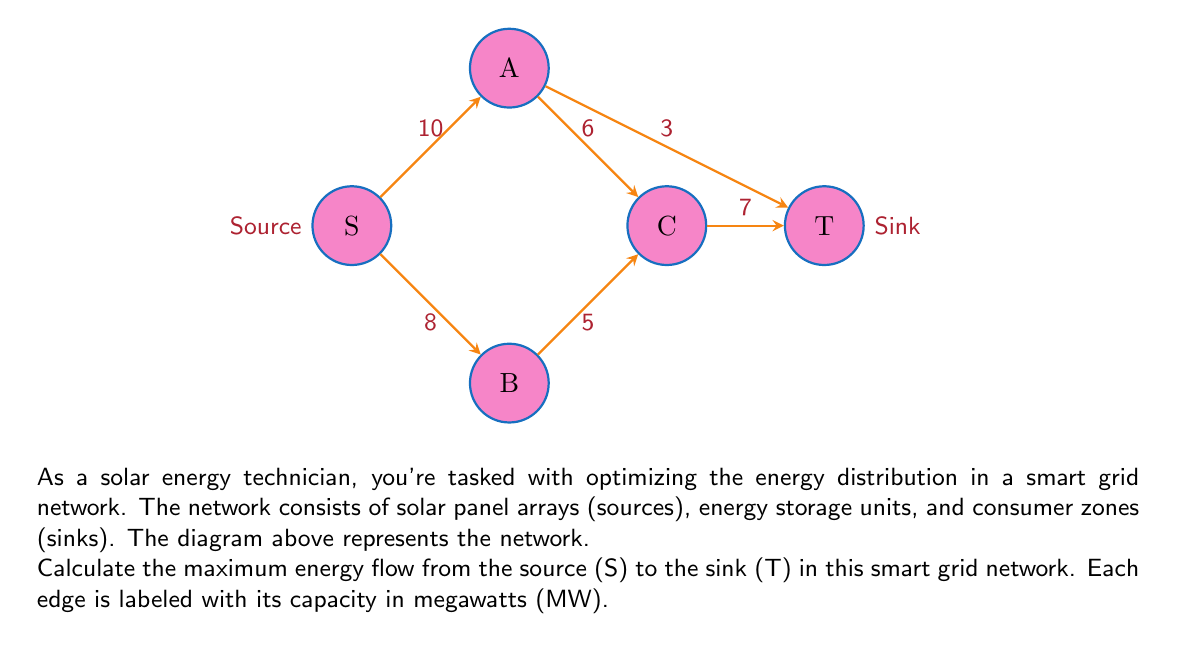Show me your answer to this math problem. To solve this problem, we'll use the Ford-Fulkerson algorithm to find the maximum flow in the network:

1) Initialize the flow to 0 for all edges.

2) Find an augmenting path from S to T:
   Path 1: S -> A -> T (min capacity = 3 MW)
   Update flow: 
   S -> A: 3/10
   A -> T: 3/3

3) Find another augmenting path:
   Path 2: S -> A -> C -> T (min capacity = 6 MW)
   Update flow:
   S -> A: 9/10
   A -> C: 6/6
   C -> T: 6/7

4) Find another augmenting path:
   Path 3: S -> B -> C -> T (min capacity = 1 MW)
   Update flow:
   S -> B: 1/8
   B -> C: 1/5
   C -> T: 7/7

5) No more augmenting paths exist, so we've reached the maximum flow.

To calculate the total flow:
$$\text{Total Flow} = \text{Flow(S -> A)} + \text{Flow(S -> B)}$$
$$\text{Total Flow} = 9 + 1 = 10 \text{ MW}$$

We can verify this by checking the flow into T:
$$\text{Flow into T} = \text{Flow(A -> T)} + \text{Flow(C -> T)}$$
$$\text{Flow into T} = 3 + 7 = 10 \text{ MW}$$

Therefore, the maximum energy flow from the source to the sink is 10 MW.
Answer: 10 MW 